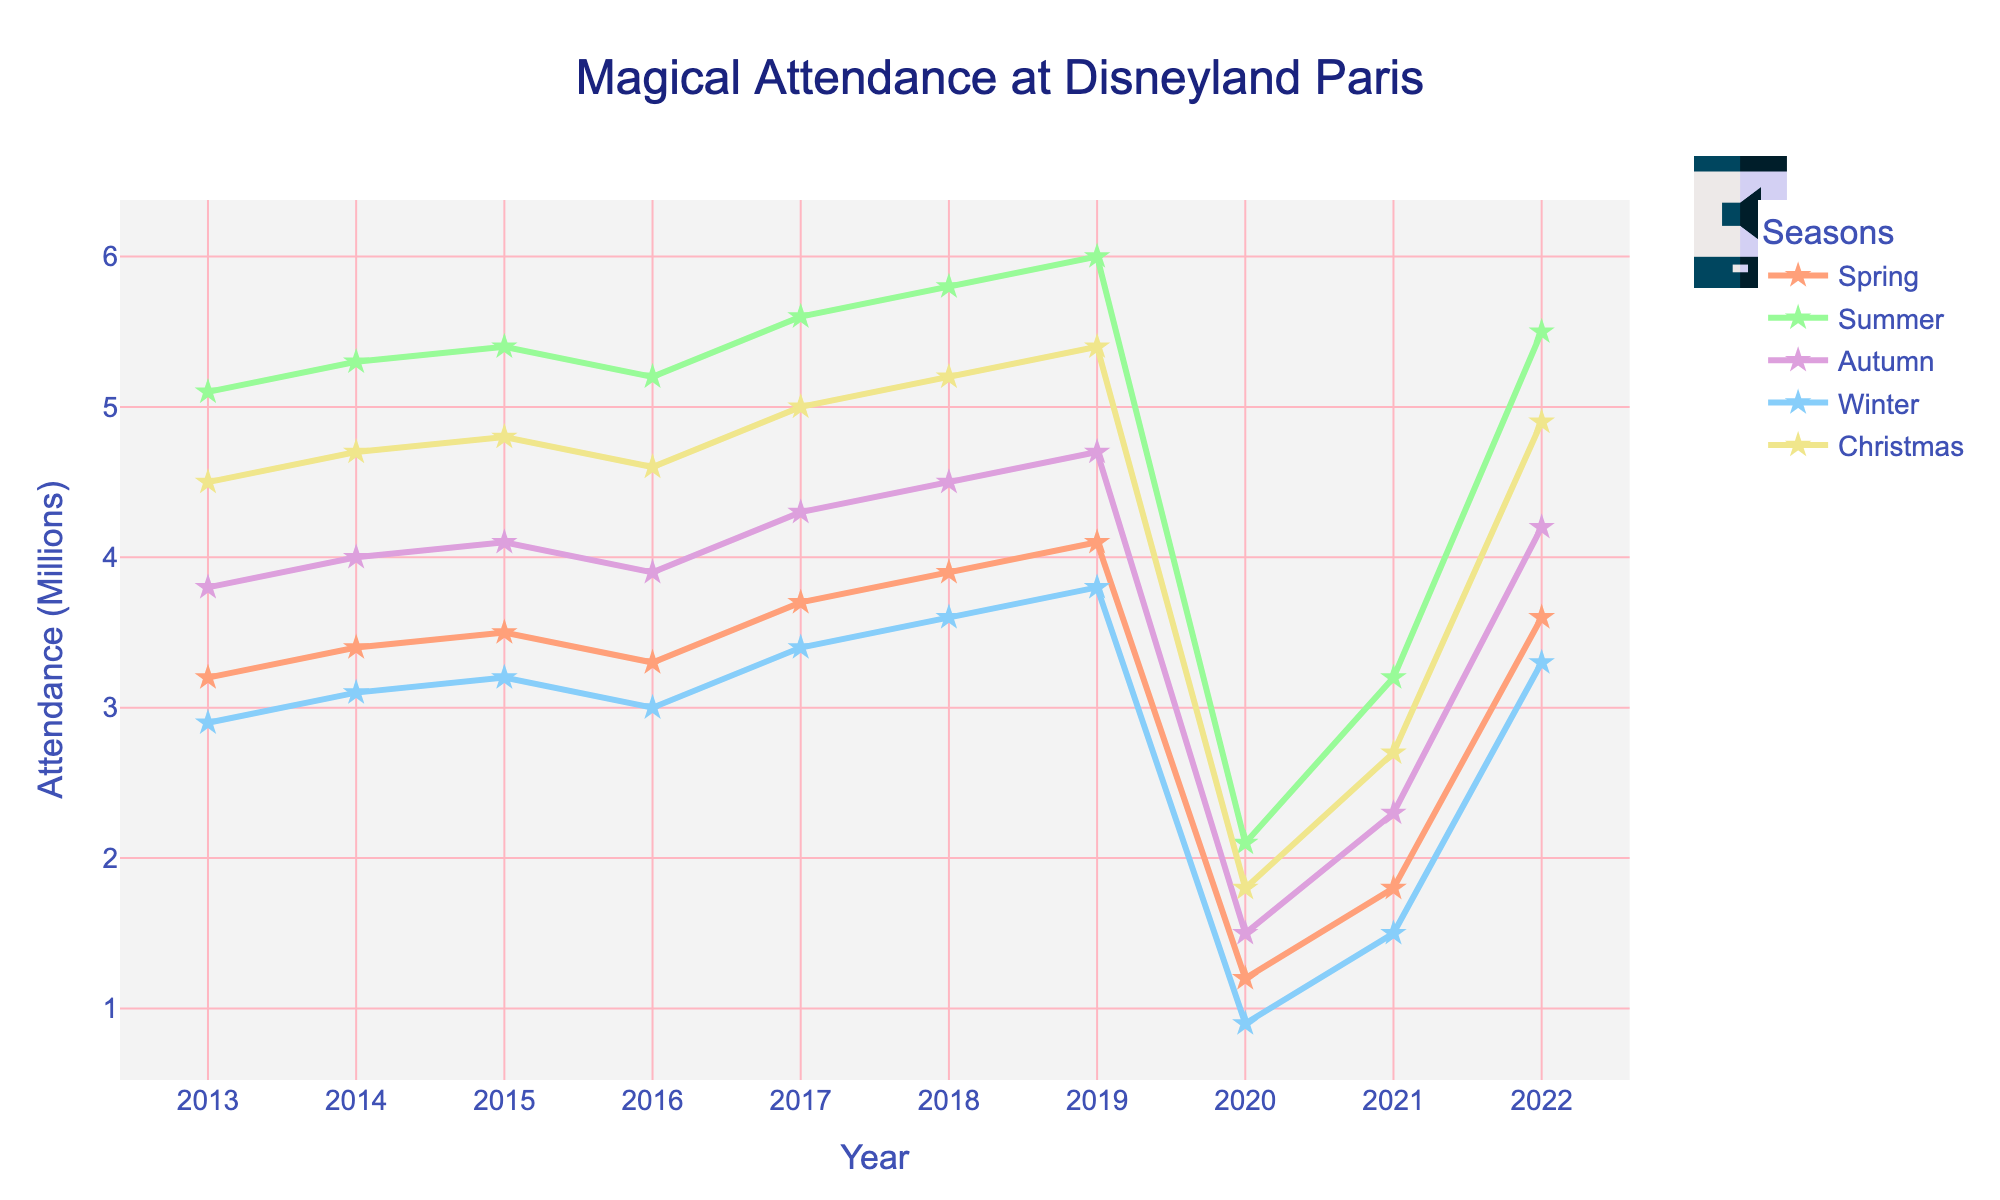Which season had the highest attendance in 2019? By looking at the line chart, check for the peak point in 2019. Find that the highest peak is for Summer.
Answer: Summer What is the difference in attendance between Summer and Winter in 2022? Look at the attendance values for Summer and Winter in 2022. Subtract Winter's value (3.3) from Summer's (5.5) to get the difference.
Answer: 2.2 How did the attendance change from 2013 to 2014 for Christmas? Check the Christmas attendance values for 2013 and 2014. Calculate the difference by subtracting the value in 2013 (4.5) from the value in 2014 (4.7).
Answer: 0.2 Which season had the lowest attendance in 2020? Check all the points for each season in 2020. The lowest point is for Winter (0.9).
Answer: Winter Calculate the average attendance for Spring over the entire period. Sum the attendance values for Spring from 2013 to 2022: (3.2 + 3.4 + 3.5 + 3.3 + 3.7 + 3.9 + 4.1 + 1.2 + 1.8 + 3.6). Divide this sum by the total number of years (10). (32.7/10 = 3.27)
Answer: 3.27 How did attendance for Autumn change from 2019 to 2021? Find the values for Autumn in 2019 and 2021 (4.7 and 2.3 respectively). Subtract the 2021 value from the 2019 value (4.7 - 2.3) to find the change.
Answer: -2.4 Which year had the biggest drop in attendance from the previous year for any season? By visual comparison, notice that the most significant drop is for Christmas between 2019 and 2020 (from 5.4 to 1.8).
Answer: 2020 What is the trend of Summer attendance over the decade? Observe the graph and notice that the Summer attendance trend increases up to 2019, drops in 2020 due to a significant event, and then starts to rise again.
Answer: Rising, then drop in 2020, then rising again Compare the attendance trend for Winter and Spring in 2021. In 2021, Winter has an attendance of 1.5, and Spring has an attendance of 1.8. Spring's attendance is slightly higher than Winter's.
Answer: Spring higher than Winter 